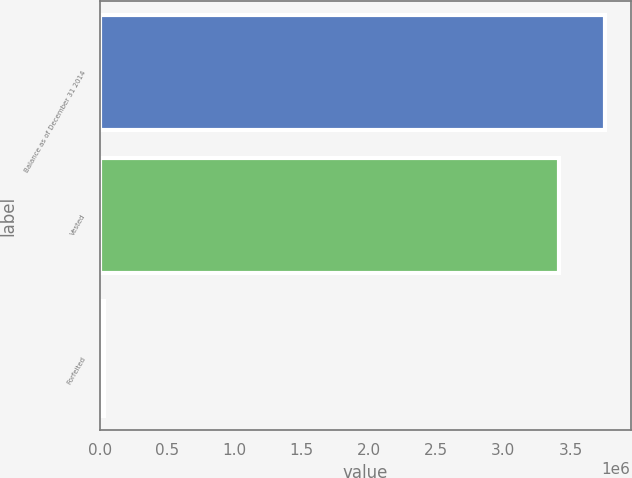Convert chart. <chart><loc_0><loc_0><loc_500><loc_500><bar_chart><fcel>Balance as of December 31 2014<fcel>Vested<fcel>Forfeited<nl><fcel>3.75875e+06<fcel>3.41704e+06<fcel>28767<nl></chart> 